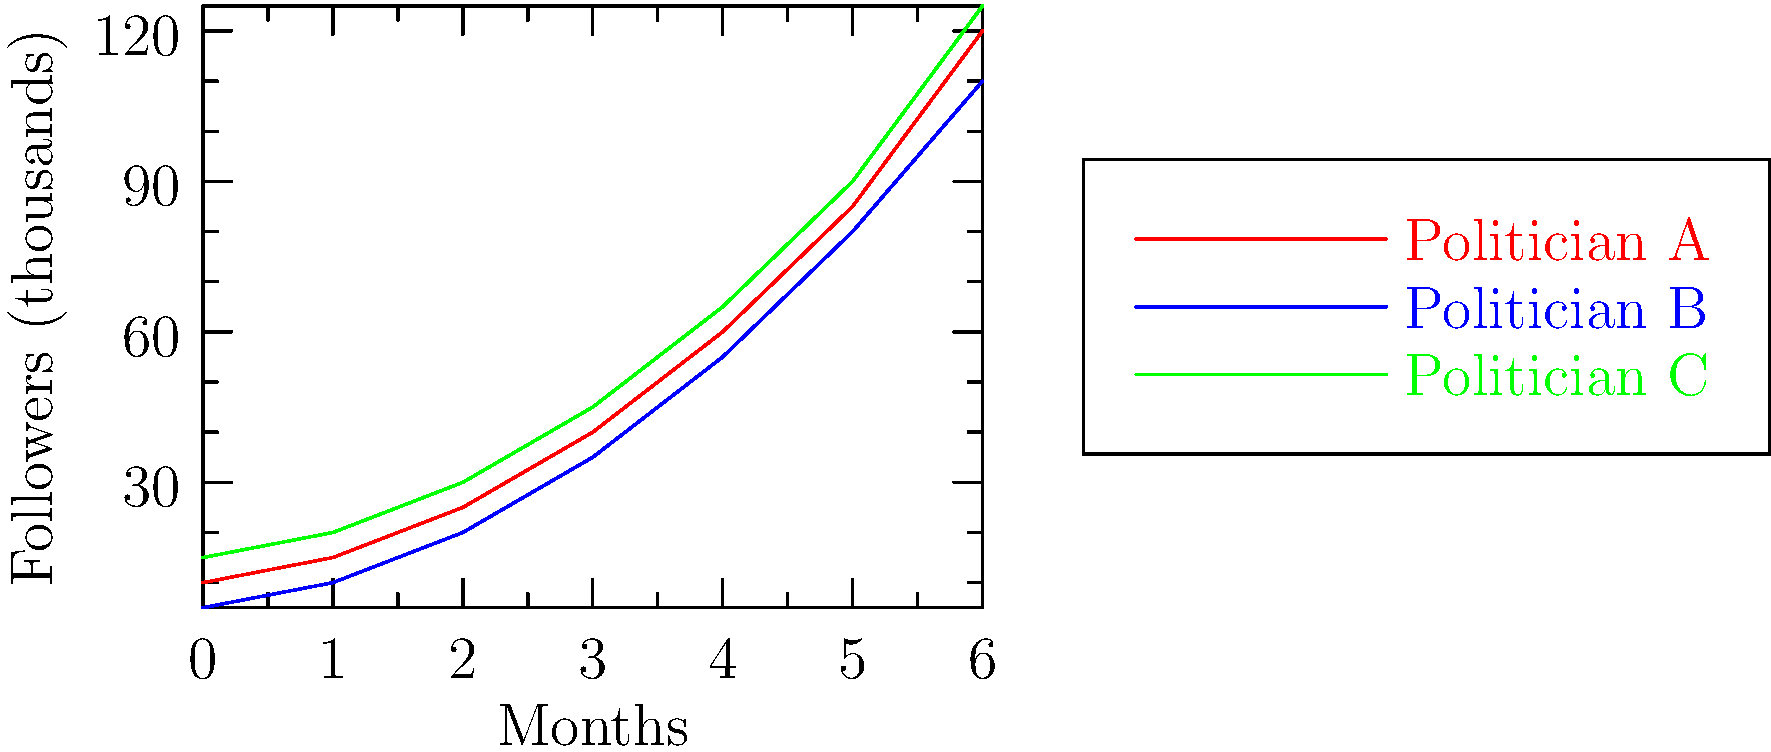The graph shows the social media follower growth of three emerging Brazilian politicians over a 6-month period. Which politician had the highest percentage increase in followers from month 0 to month 6? To determine which politician had the highest percentage increase, we need to calculate the percentage change for each:

1. Politician A:
   Initial followers: 10,000
   Final followers: 120,000
   Percentage increase = $\frac{120,000 - 10,000}{10,000} \times 100\% = 1100\%$

2. Politician B:
   Initial followers: 5,000
   Final followers: 110,000
   Percentage increase = $\frac{110,000 - 5,000}{5,000} \times 100\% = 2100\%$

3. Politician C:
   Initial followers: 15,000
   Final followers: 125,000
   Percentage increase = $\frac{125,000 - 15,000}{15,000} \times 100\% = 733.33\%$

Comparing the results, Politician B had the highest percentage increase at 2100%.
Answer: Politician B 